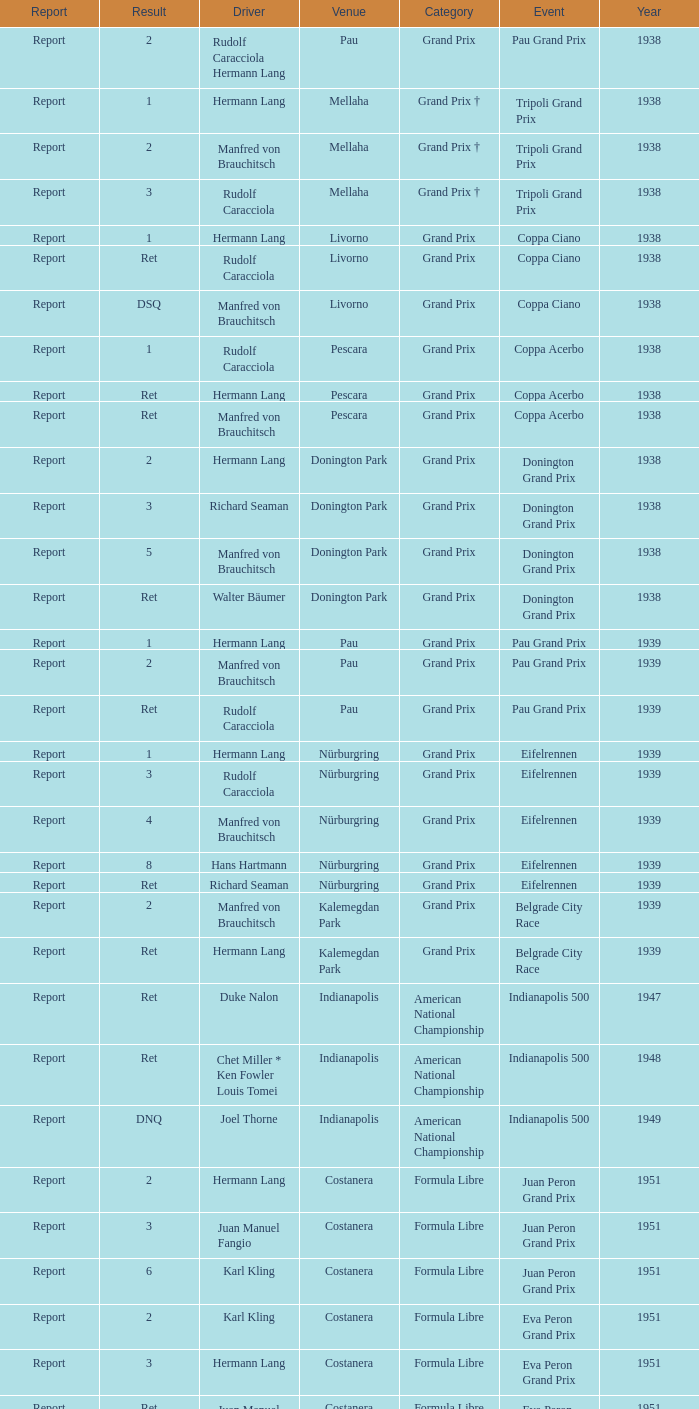When did Hans Hartmann drive? 1.0. 